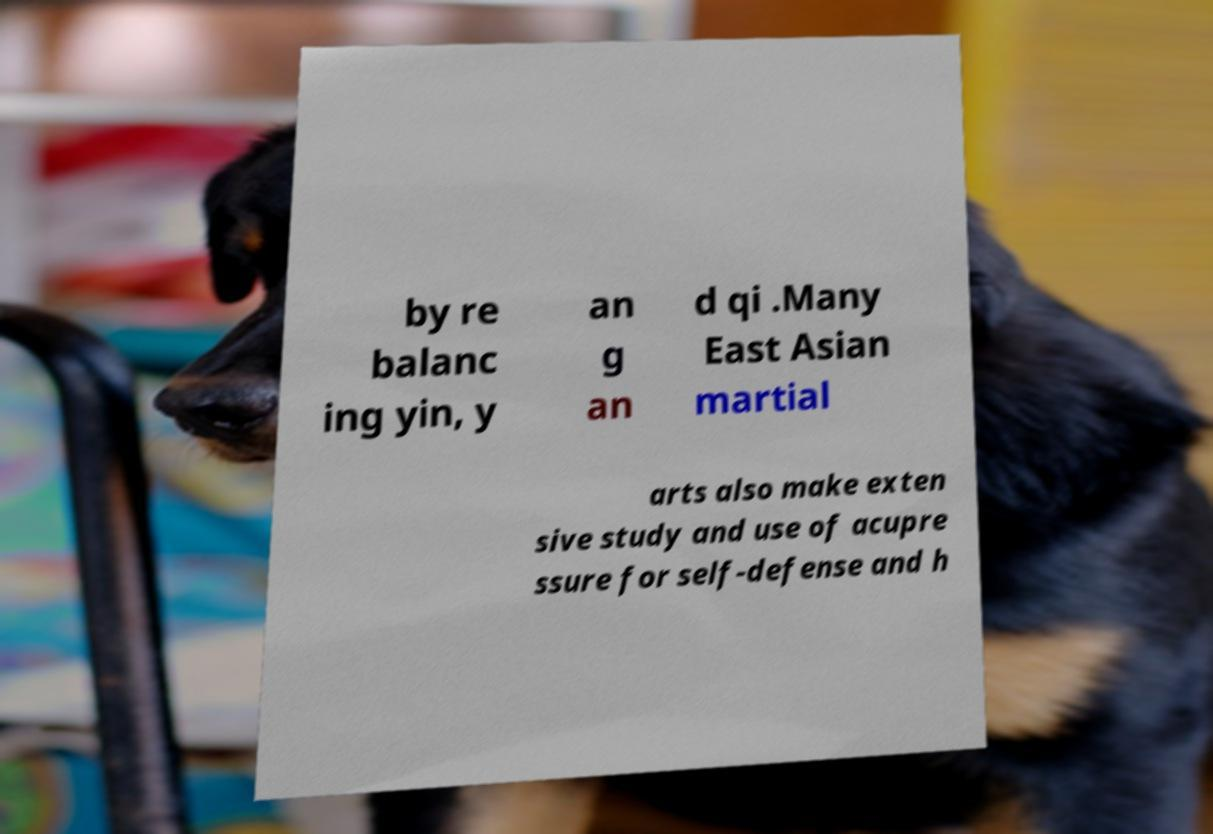Could you extract and type out the text from this image? by re balanc ing yin, y an g an d qi .Many East Asian martial arts also make exten sive study and use of acupre ssure for self-defense and h 